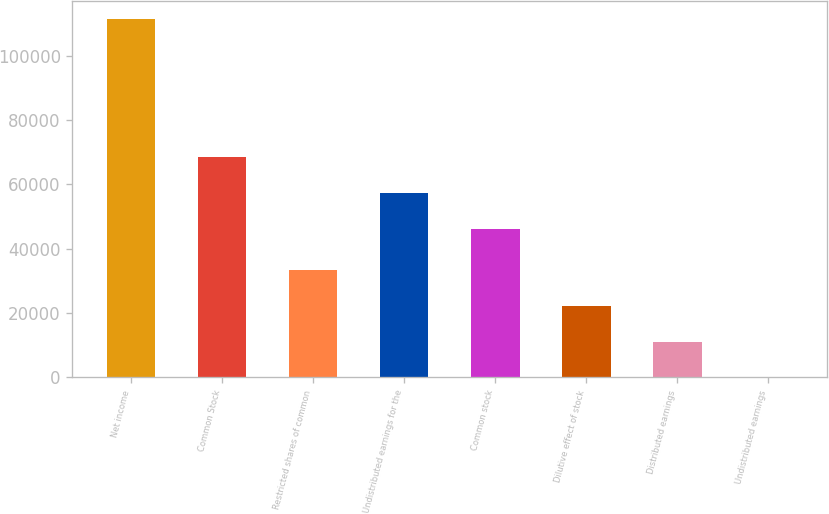Convert chart. <chart><loc_0><loc_0><loc_500><loc_500><bar_chart><fcel>Net income<fcel>Common Stock<fcel>Restricted shares of common<fcel>Undistributed earnings for the<fcel>Common stock<fcel>Dilutive effect of stock<fcel>Distributed earnings<fcel>Undistributed earnings<nl><fcel>111332<fcel>68416.3<fcel>33399.8<fcel>57283.2<fcel>46150<fcel>22266.7<fcel>11133.5<fcel>0.32<nl></chart> 